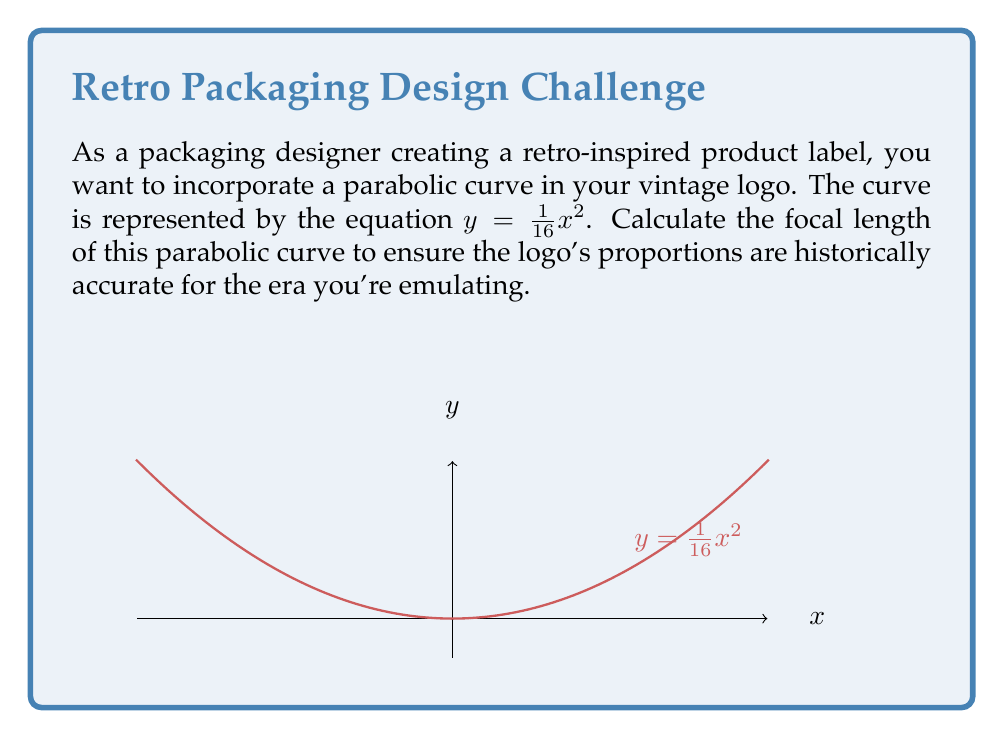Teach me how to tackle this problem. To find the focal length of a parabola, we can use the general form of a parabola equation:

$$y = \frac{1}{4p}x^2$$

where $p$ is the focal length.

In our case, we have:

$$y = \frac{1}{16}x^2$$

Comparing these two equations, we can see that:

$$\frac{1}{4p} = \frac{1}{16}$$

To solve for $p$:

1) Multiply both sides by $4p$:
   $$1 = \frac{4p}{16}$$

2) Multiply both sides by 16:
   $$16 = 4p$$

3) Divide both sides by 4:
   $$4 = p$$

Therefore, the focal length of the parabolic curve is 4 units.
Answer: $p = 4$ units 